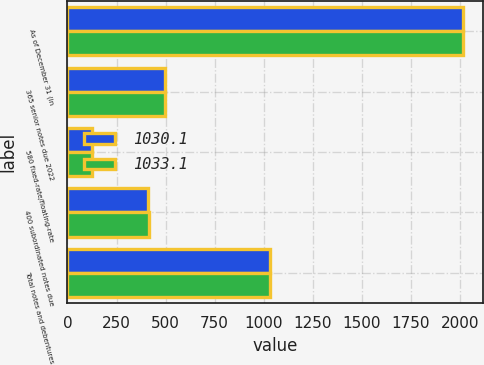<chart> <loc_0><loc_0><loc_500><loc_500><stacked_bar_chart><ecel><fcel>As of December 31 (in<fcel>365 senior notes due 2022<fcel>580 fixed-rate/floating-rate<fcel>400 subordinated notes due<fcel>Total notes and debentures<nl><fcel>1030.1<fcel>2016<fcel>496.5<fcel>125<fcel>408.6<fcel>1030.1<nl><fcel>1033.1<fcel>2015<fcel>496<fcel>123.7<fcel>413.4<fcel>1033.1<nl></chart> 